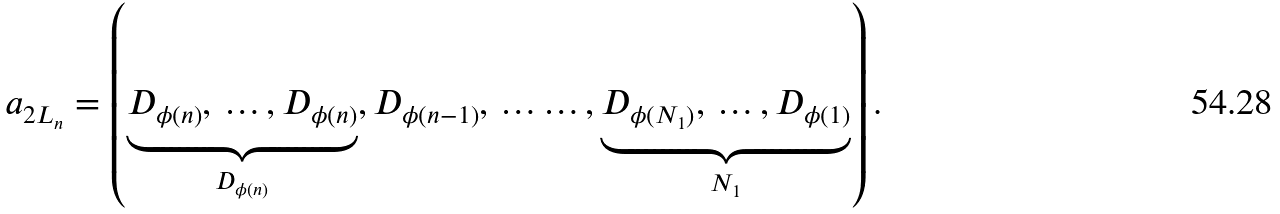<formula> <loc_0><loc_0><loc_500><loc_500>{ a } _ { 2 L _ { n } } = \left ( \underbrace { D _ { \phi ( n ) } , \, \dots , D _ { \phi ( n ) } } _ { D _ { \phi ( n ) } } , D _ { \phi ( n - 1 ) } , \, \dots \dots , \underbrace { D _ { \phi ( N _ { 1 } ) } , \, \dots , D _ { \phi ( 1 ) } } _ { N _ { 1 } } \right ) .</formula> 